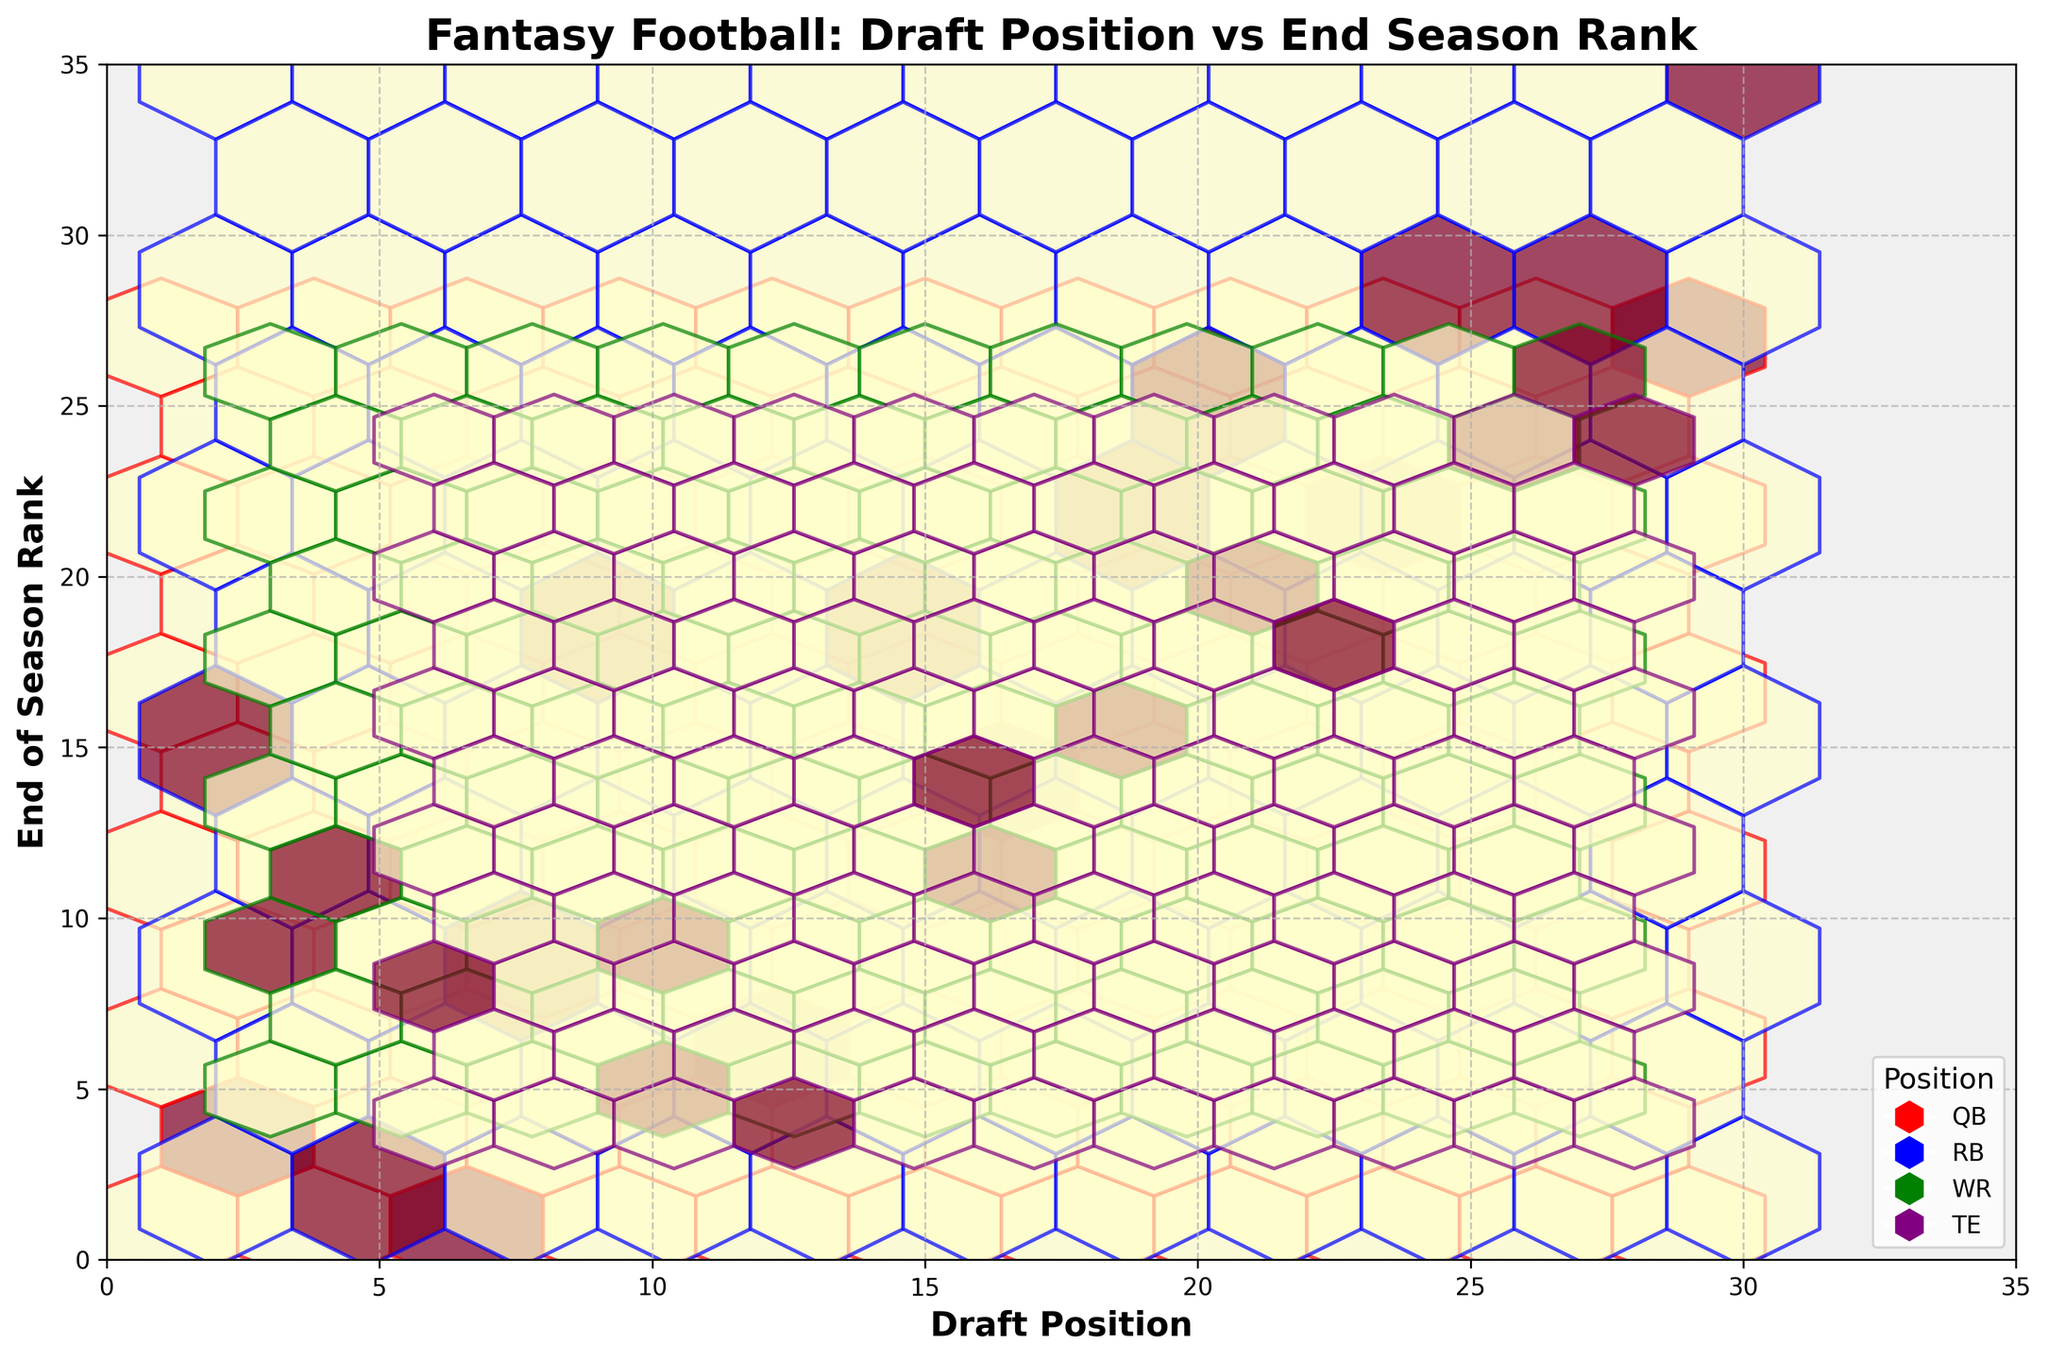What does the title of the plot say? The title of the plot indicates what the figure is about. It reads "Fantasy Football: Draft Position vs End Season Rank," which suggests that the plot is examining the relationship between where players were drafted and their rankings at the end of the season.
Answer: Fantasy Football: Draft Position vs End Season Rank Which position appears to have the highest concentration of low draft positions and low end-of-season ranks? By observing the plot, the positions marked in red (QB) appear to have a high concentration of points close to the origin (low draft positions and low end-of-season ranks). This suggests that quarterbacks often drafted early tend to rank well by the end of the season.
Answer: QB How many positional categories are represented in the legend? The legend at the lower right of the plot lists four positional categories, each with a distinct color: QB (red), RB (blue), WR (green), and TE (purple).
Answer: Four Which axis represents the Draft Position? The x-axis, labeled "Draft Position," denotes where players were selected during the draft. The draft position is usually based on numerical order, starting from 1.
Answer: x-axis Among the positions, which seems to show the most diverse range of end-of-season rankings? The positions denoted in blue (RB) appear to show a wide spread along the y-axis, indicating a variety of end-of-season rankings, from very high to very low.
Answer: RB What appears to be the relationship between draft position and end-of-season ranks for WRs? WRs (green) show a scattered pattern with both high and low end-of-season ranks regardless of their draft positions. This suggests no clear correlation, meaning those players can perform variably whether drafted early or late.
Answer: No clear correlation Comparing TEs' (purple) draft positions to end-of-season ranks, do early drafted TEs perform significantly better than those drafted later in the season? TEs (purple) drafted earlier generally rank better at the end of the season, as indicated by more purple clusters appearing closer to the origin of the plot. This trend becomes less distinct as the draft position number increases.
Answer: Yes Are there more data points closer to the origin (1,1) for any particular position? Yes, quarterbacks (red) have multiple data points close to the origin, suggesting that players drafted early in this position tend to finish the season highly ranked.
Answer: Yes What can we infer about the density of the data points for RBs based on the hexbin plot? The hexbin plot utilization using color intensity indicates high density among RBs (blue) across a broader range, suggesting variability in RB performance relative to their draft positions. More densely populated bins suggest clusters of similar performance.
Answer: High variability 